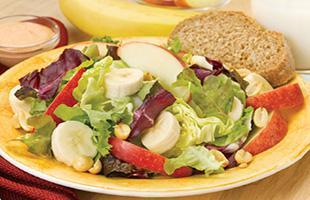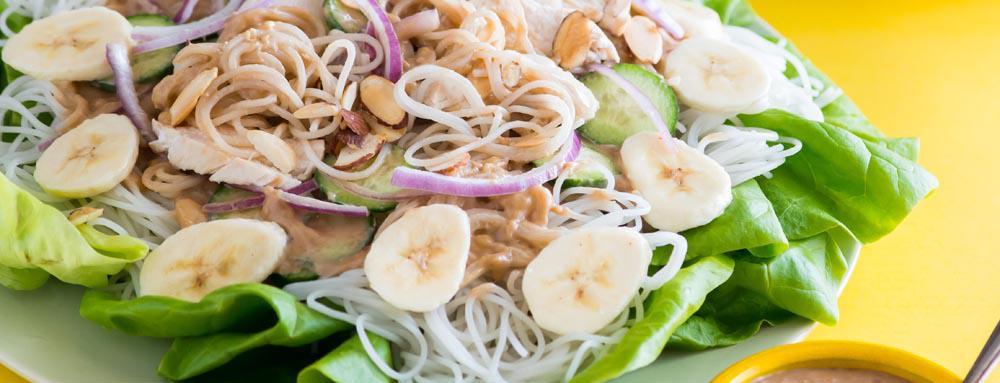The first image is the image on the left, the second image is the image on the right. Given the left and right images, does the statement "In at least one image there is a salad on a plate with apple and sliced red onions." hold true? Answer yes or no. Yes. The first image is the image on the left, the second image is the image on the right. Evaluate the accuracy of this statement regarding the images: "One image shows ingredients sitting on a bed of green lettuce leaves on a dish.". Is it true? Answer yes or no. Yes. 